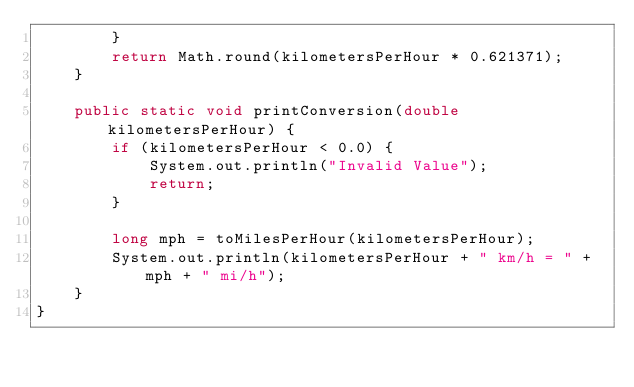Convert code to text. <code><loc_0><loc_0><loc_500><loc_500><_Java_>        }
        return Math.round(kilometersPerHour * 0.621371);
    }

    public static void printConversion(double kilometersPerHour) {
        if (kilometersPerHour < 0.0) {
            System.out.println("Invalid Value");
            return;
        }

        long mph = toMilesPerHour(kilometersPerHour);
        System.out.println(kilometersPerHour + " km/h = " + mph + " mi/h");
    }
}</code> 